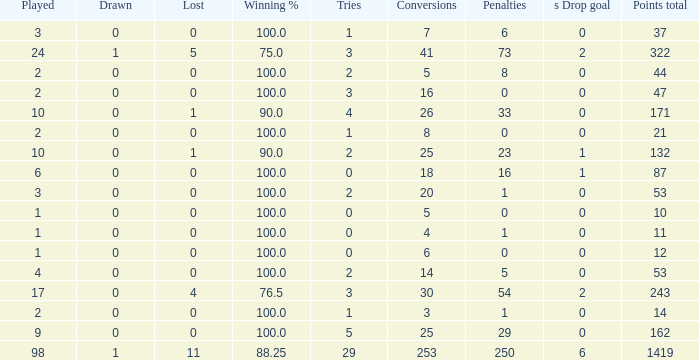How many tie units did he hold when he had 1 penalty and in excess of 20 conversions? None. 